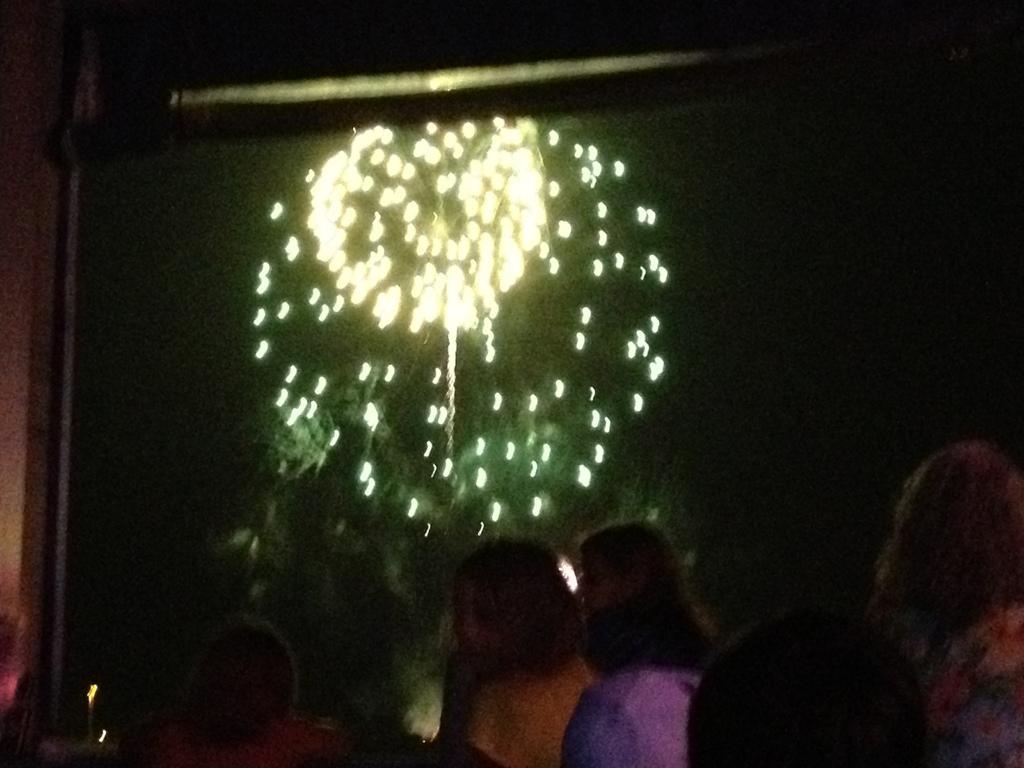How would you summarize this image in a sentence or two? In this image I can see the group of people. In-front of these people I can see the lights and there is a black background. 